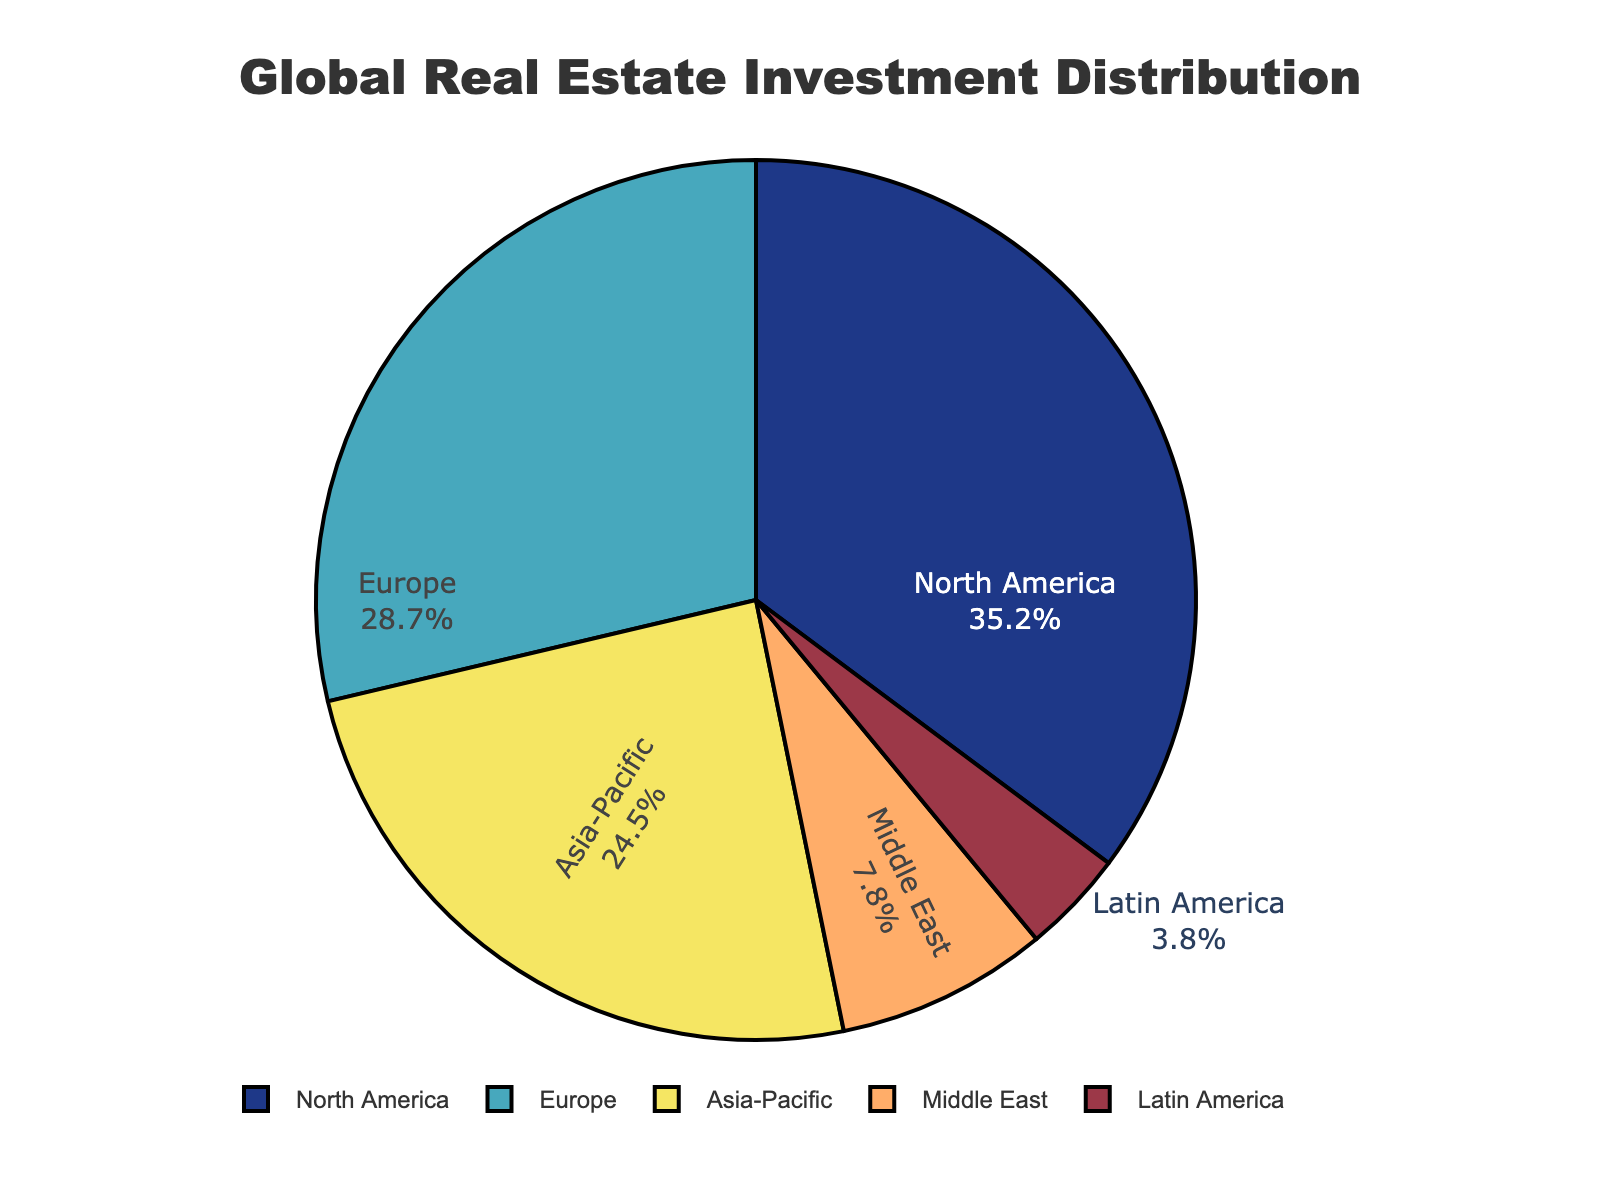Which region has the highest percentage of global real estate investment? The figure shows the percentage distribution of global real estate investment by region, indicating that North America has the highest percentage at 35.2%.
Answer: North America Which region has the lowest percentage of global real estate investment? By looking at the labeled percentages on the pie chart, Latin America has the lowest percentage at 3.8%.
Answer: Latin America What is the total percentage of global real estate investment held by Europe and Asia-Pacific combined? Adding the percentages for Europe (28.7%) and Asia-Pacific (24.5%) gives a total of 28.7 + 24.5 = 53.2%.
Answer: 53.2% How much greater is North America's investment compared to the Middle East's investment? North America's percentage is 35.2%, and the Middle East's percentage is 7.8%. The difference is 35.2 - 7.8 = 27.4%.
Answer: 27.4% What is the average percentage of global real estate investment across the five regions? Summing all percentages (35.2 + 28.7 + 24.5 + 7.8 + 3.8) gives 100%. Dividing by the number of regions (5) yields the average: 100 / 5 = 20%.
Answer: 20% What share of global real estate investment is held by regions other than North America? To find this, subtract North America's percentage from 100%: 100 - 35.2 = 64.8%.
Answer: 64.8% Which region's share of global real estate investment is closest to 25%? By comparing the percentages of each region, Asia-Pacific has a percentage closest to 25% at 24.5%.
Answer: Asia-Pacific Are there more regions with a percentage above or below 20%? There are three regions with percentages above 20% (North America, Europe, Asia-Pacific) and two regions below 20% (Middle East, Latin America). Thus, more regions have percentages above 20%.
Answer: Above Is Europe’s share of the global real estate investment higher or lower than North America’s? Europe's percentage is 28.7%, while North America's percentage is 35.2%. Thus, Europe’s share is lower than North America’s.
Answer: Lower 